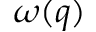Convert formula to latex. <formula><loc_0><loc_0><loc_500><loc_500>\omega ( q )</formula> 